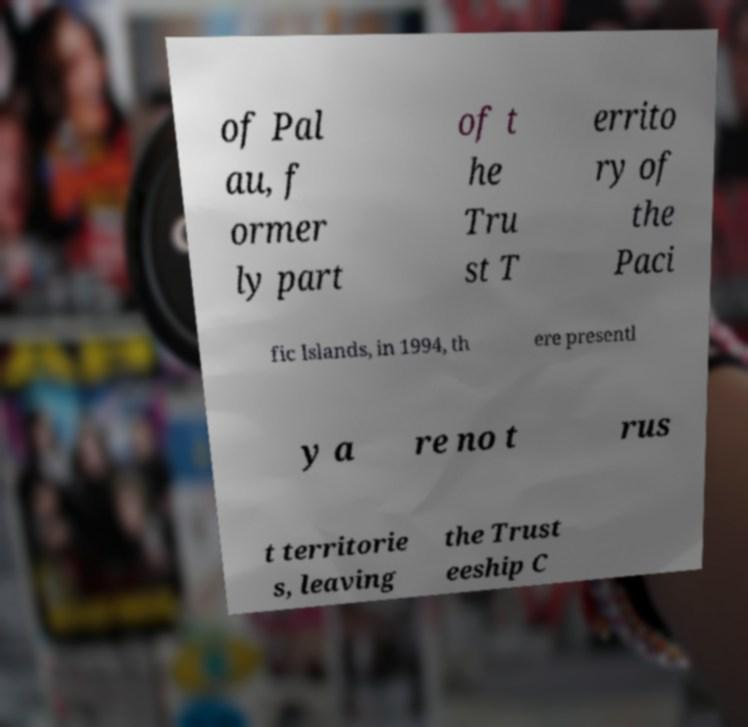Could you extract and type out the text from this image? of Pal au, f ormer ly part of t he Tru st T errito ry of the Paci fic Islands, in 1994, th ere presentl y a re no t rus t territorie s, leaving the Trust eeship C 